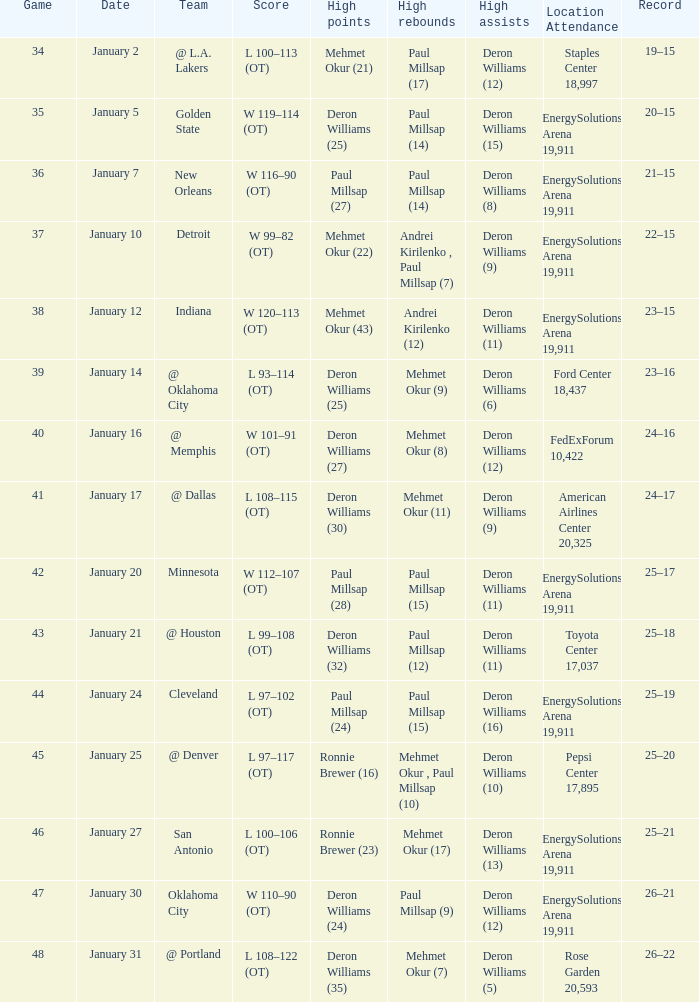Who had the high rebounds of the game that Deron Williams (5) had the high assists? Mehmet Okur (7). 